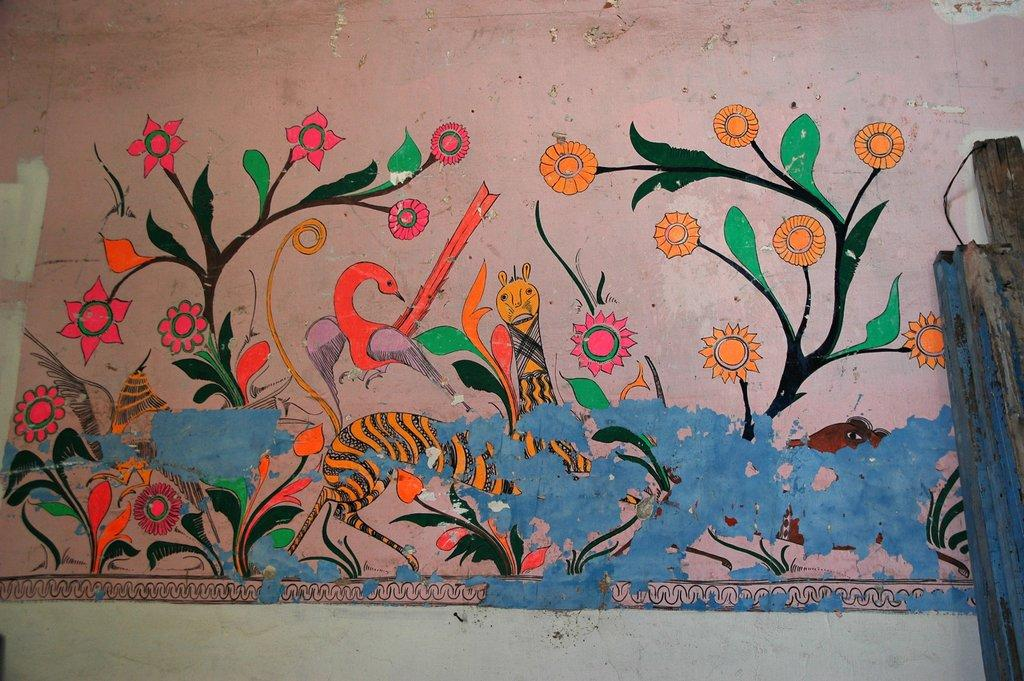What is depicted on the wall in the image? There is a painting on the wall in the image. What elements are included in the painting? The painting contains plants with flowers, birds, and animals. Where are the wooden sticks located in the image? The wooden sticks are placed on the right side of the image. Can you tell me how much sugar is in the painting? There is no sugar present in the painting; it contains plants, birds, and animals. Is there a seashore visible in the painting? There is no seashore depicted in the painting; it focuses on plants, birds, and animals. 